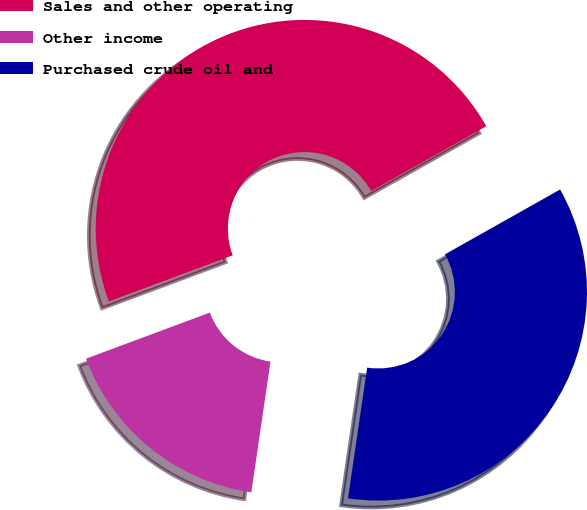<chart> <loc_0><loc_0><loc_500><loc_500><pie_chart><fcel>Sales and other operating<fcel>Other income<fcel>Purchased crude oil and<nl><fcel>47.51%<fcel>17.01%<fcel>35.48%<nl></chart> 